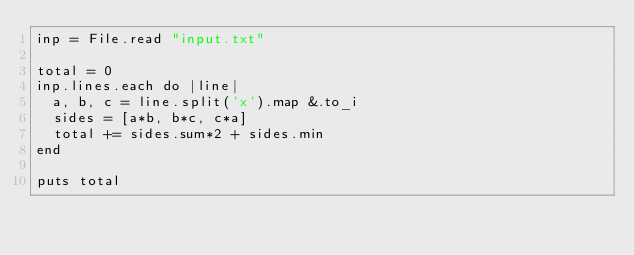<code> <loc_0><loc_0><loc_500><loc_500><_Crystal_>inp = File.read "input.txt"

total = 0
inp.lines.each do |line|
  a, b, c = line.split('x').map &.to_i
  sides = [a*b, b*c, c*a]
  total += sides.sum*2 + sides.min
end

puts total
</code> 